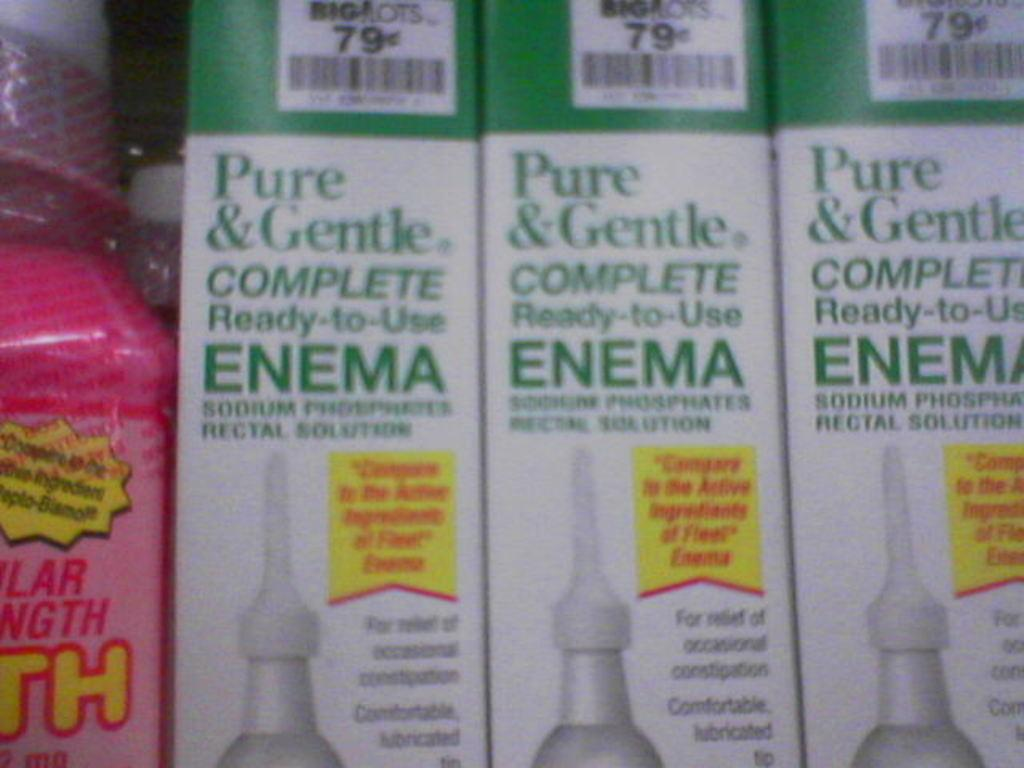<image>
Give a short and clear explanation of the subsequent image. Three boxes of ready to use Enema at Biglots 